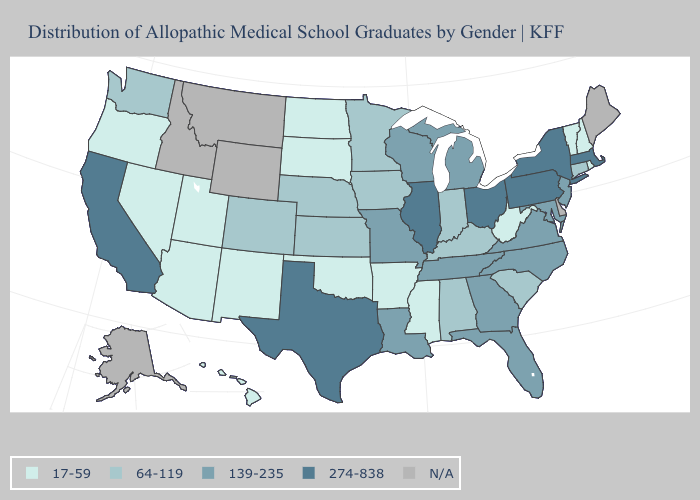What is the lowest value in the USA?
Write a very short answer. 17-59. Does the map have missing data?
Short answer required. Yes. Name the states that have a value in the range 64-119?
Give a very brief answer. Alabama, Colorado, Connecticut, Indiana, Iowa, Kansas, Kentucky, Minnesota, Nebraska, South Carolina, Washington. What is the lowest value in the USA?
Be succinct. 17-59. What is the value of Oregon?
Quick response, please. 17-59. Among the states that border Michigan , which have the highest value?
Short answer required. Ohio. Name the states that have a value in the range N/A?
Concise answer only. Alaska, Delaware, Idaho, Maine, Montana, Wyoming. Does South Carolina have the lowest value in the USA?
Quick response, please. No. What is the value of Missouri?
Concise answer only. 139-235. Does California have the highest value in the West?
Give a very brief answer. Yes. What is the highest value in the USA?
Short answer required. 274-838. What is the lowest value in states that border West Virginia?
Answer briefly. 64-119. What is the value of New Hampshire?
Write a very short answer. 17-59. Does the first symbol in the legend represent the smallest category?
Keep it brief. Yes. Does Florida have the highest value in the USA?
Give a very brief answer. No. 